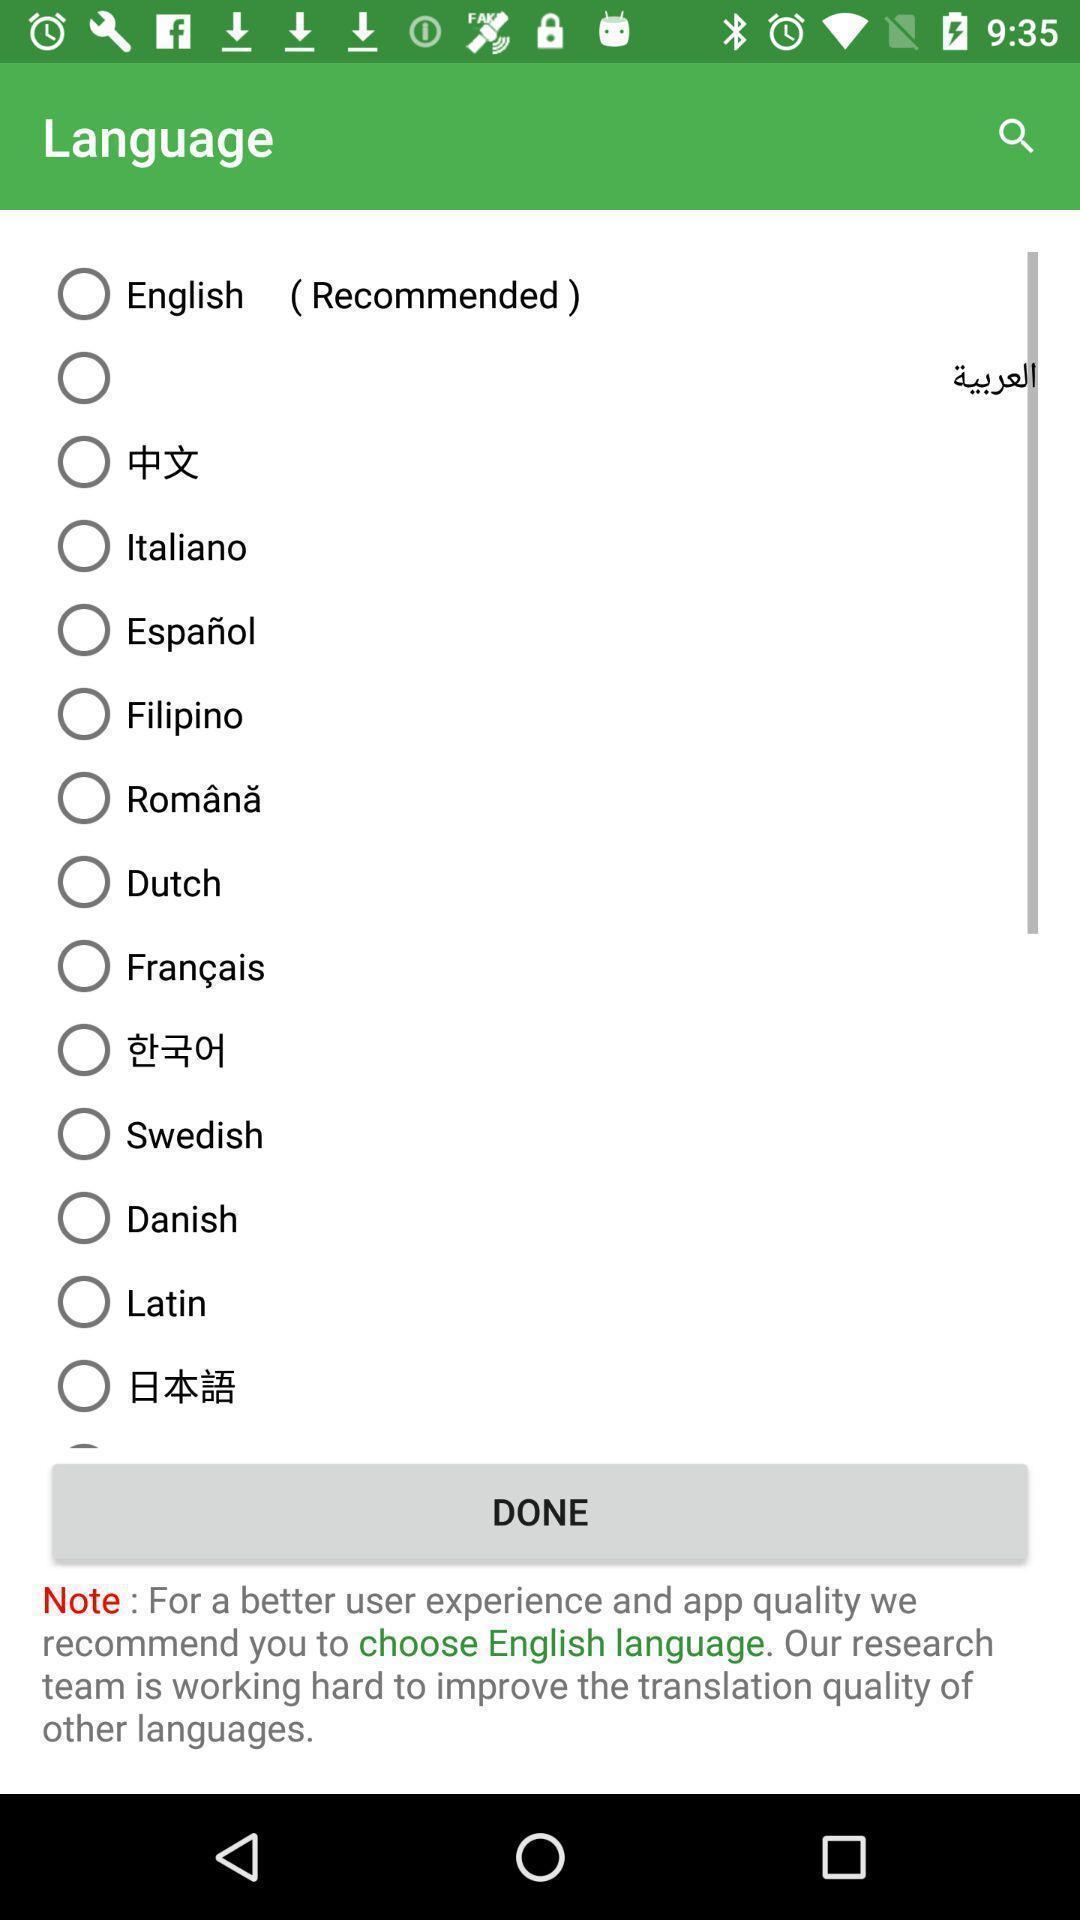Please provide a description for this image. Page showing the listings of language selection. 